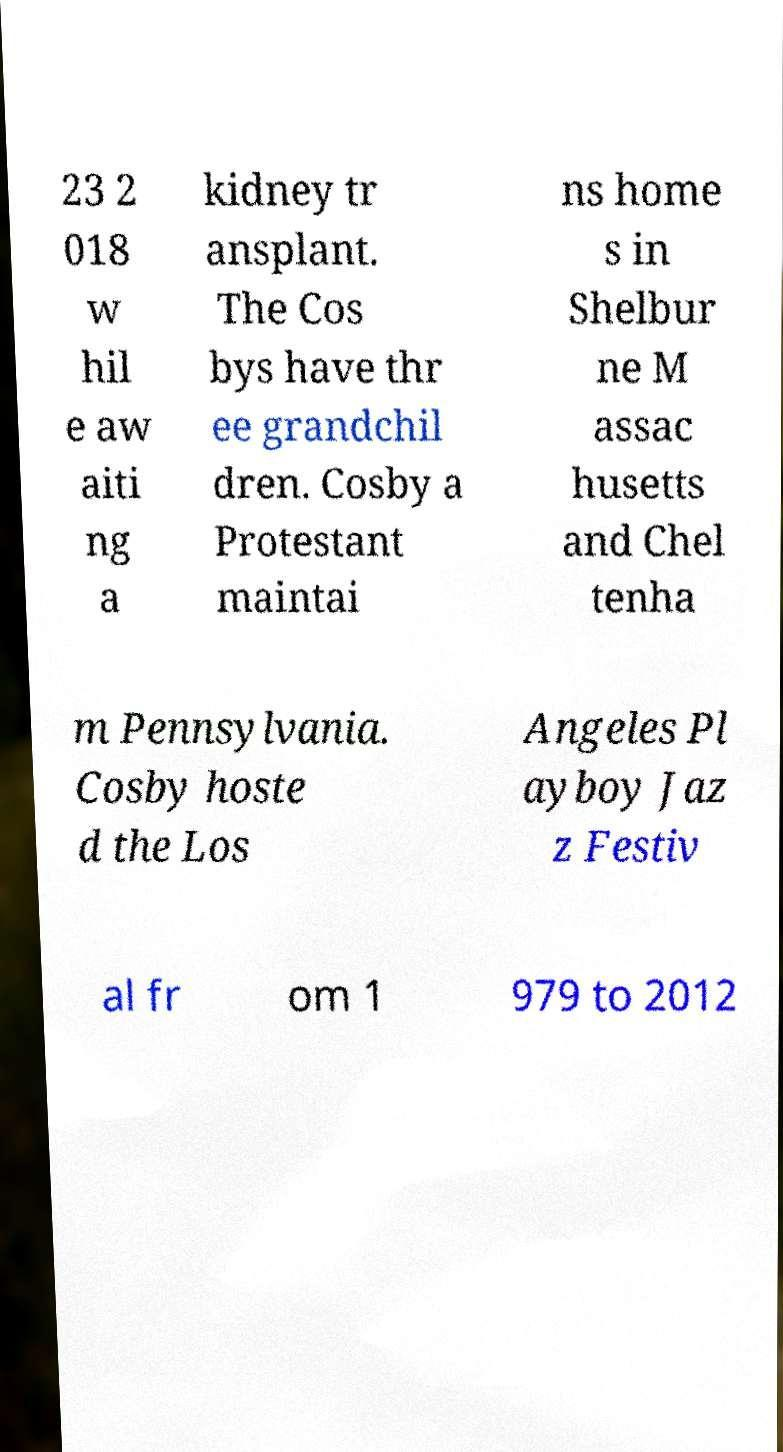Could you assist in decoding the text presented in this image and type it out clearly? 23 2 018 w hil e aw aiti ng a kidney tr ansplant. The Cos bys have thr ee grandchil dren. Cosby a Protestant maintai ns home s in Shelbur ne M assac husetts and Chel tenha m Pennsylvania. Cosby hoste d the Los Angeles Pl ayboy Jaz z Festiv al fr om 1 979 to 2012 